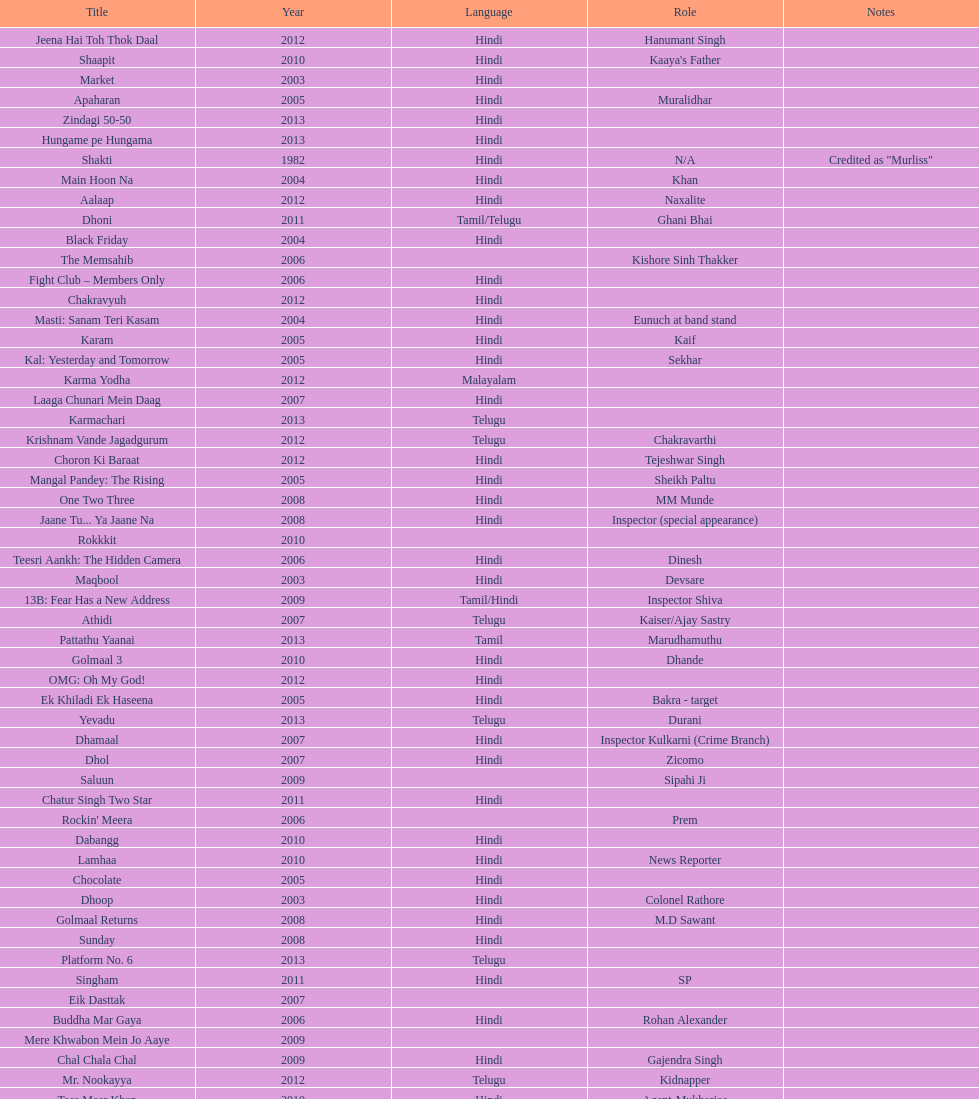What was the last malayalam film this actor starred in? Karma Yodha. 